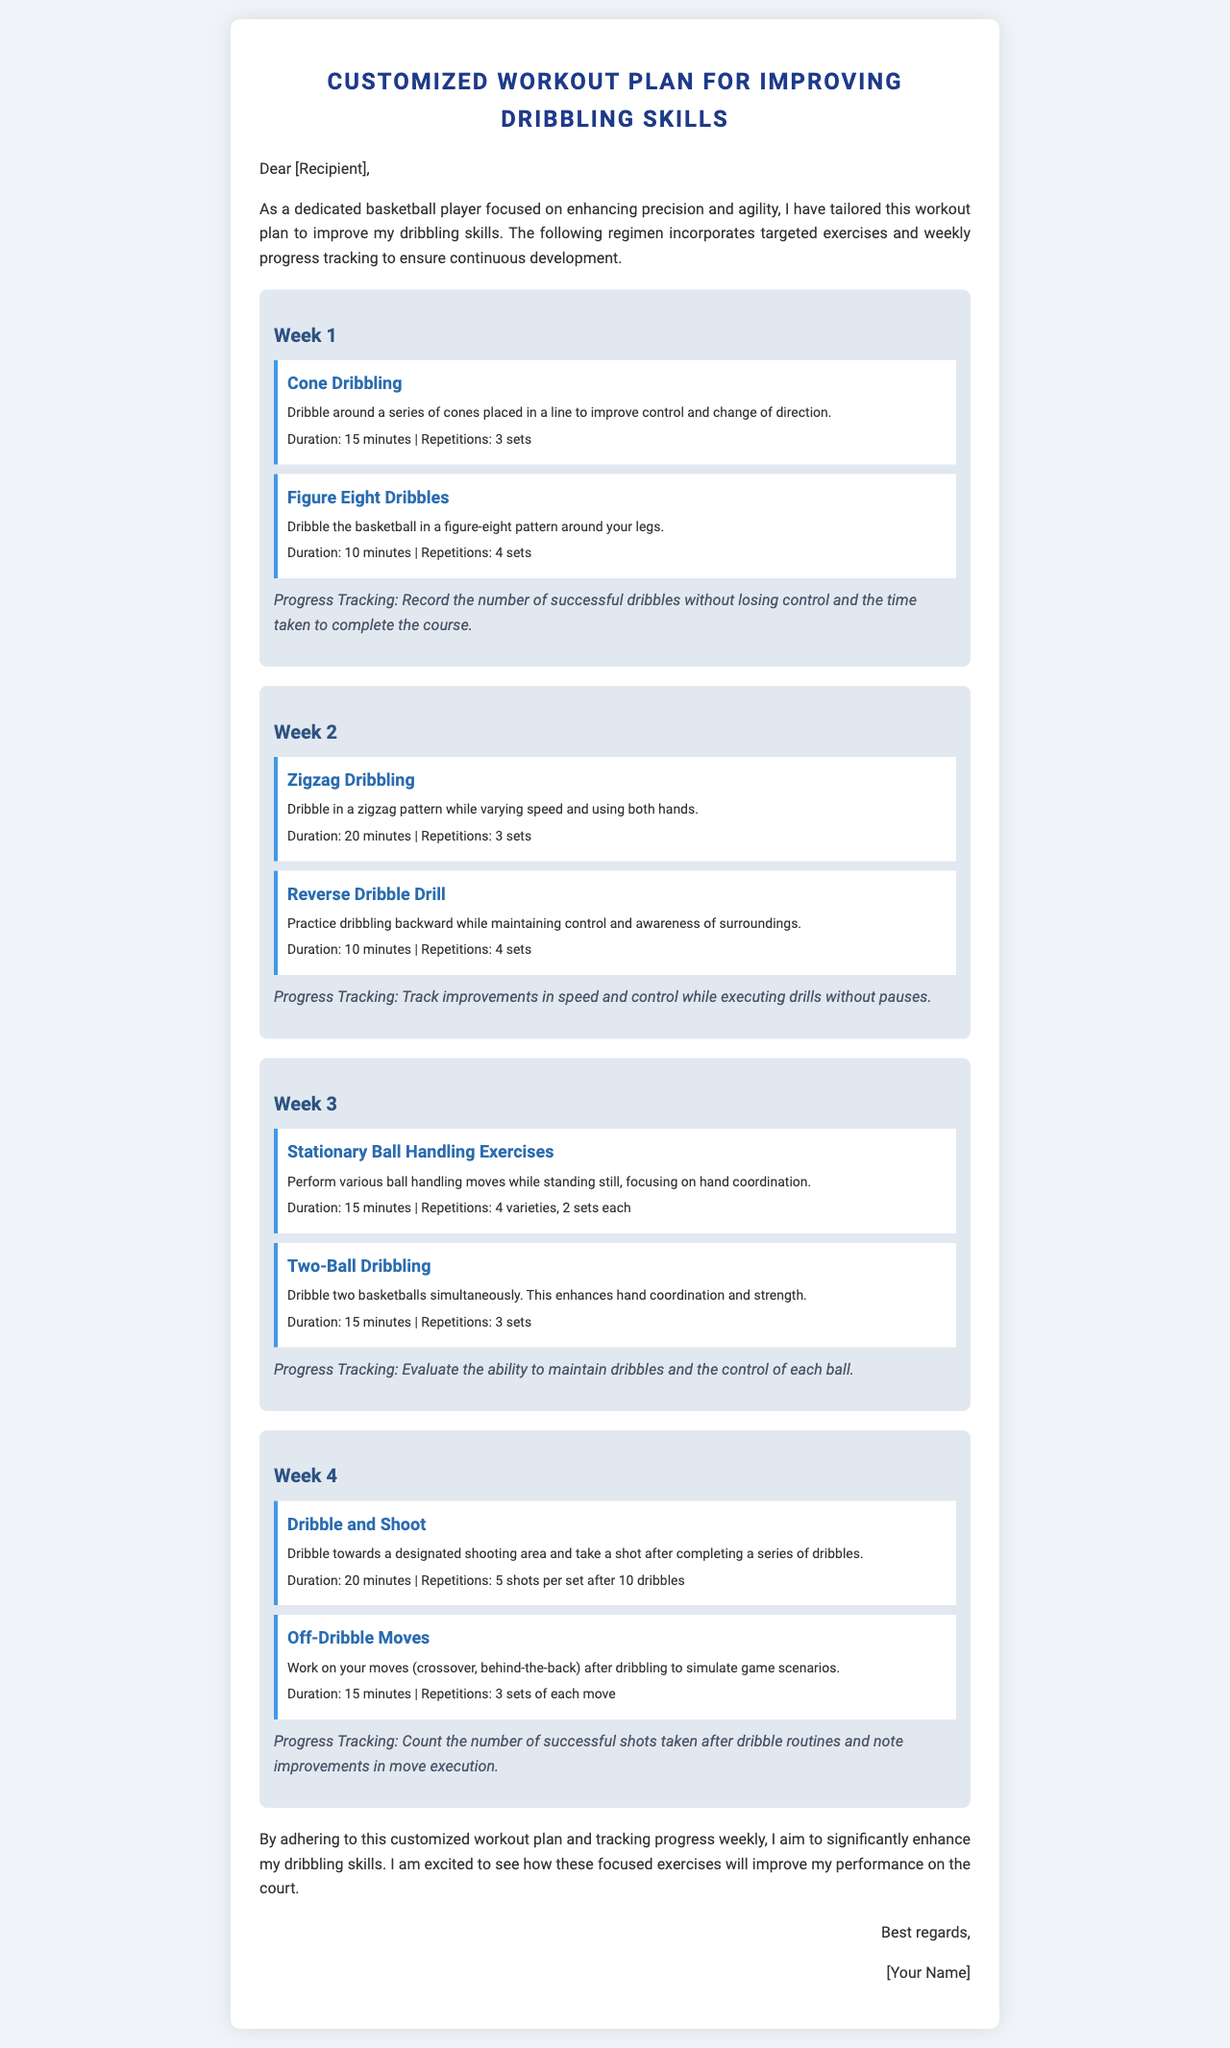What is the title of the document? The title is explicitly stated at the top of the document, showcasing the focus of the content.
Answer: Customized Workout Plan for Improving Dribbling Skills How long is the Cone Dribbling exercise? Each exercise section lists the duration for completion, with Cone Dribbling specifically mentioned.
Answer: 15 minutes What is the focus of Week 2 exercises? The description for the week's activities highlights the key skills targeted in that week.
Answer: Speed and control How many sets are recommended for Two-Ball Dribbling? The number of repetitions for each exercise is stated within its description, particularly for Two-Ball Dribbling.
Answer: 3 sets What is the main objective of the customized workout plan? The introduction outlines the primary goal of the entire workout plan.
Answer: Enhance precision and agility Which exercise emphasizes hand coordination? By reviewing the exercises in each week, one can identify which specifically targets hand coordination.
Answer: Two-Ball Dribbling What is the progress tracking method in Week 1? Each week's progress tracking is clearly stated alongside the exercises, detailing what should be recorded.
Answer: Number of successful dribbles without losing control How many varieties are included in the Stationary Ball Handling Exercises? This detail is specified under the exercise description for that specific week.
Answer: 4 varieties What is recommended after completing 10 dribbles in Week 4? The plan outlines the actions that should follow after the dribbling exercise in that week.
Answer: Take a shot 